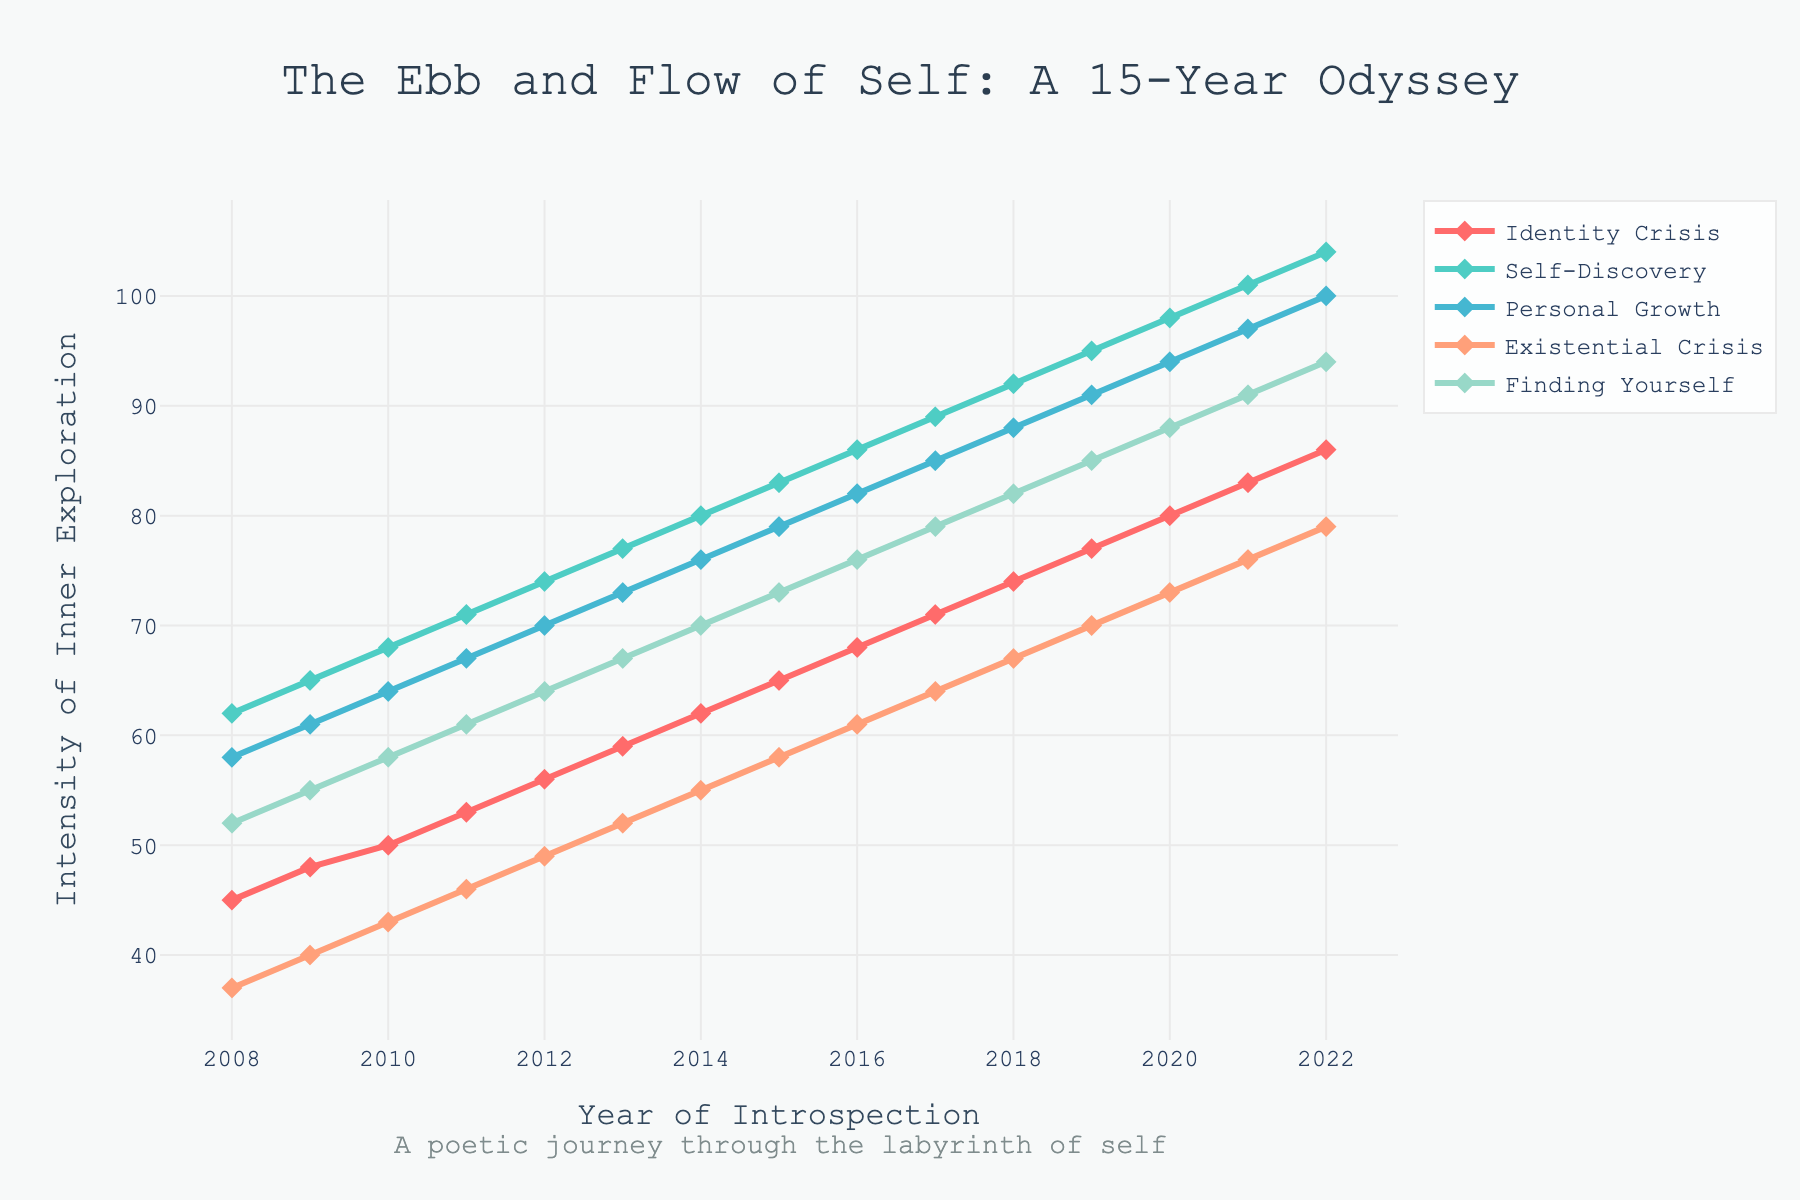What is the overall trend in Google searches for "Identity Crisis" over the past 15 years? The trend for "Identity Crisis" increases steadily from 45 in 2008 to 86 in 2022, showing a consistent upward trajectory.
Answer: Steady upward trend Which year saw the highest Google search volume for "Personal Growth"? By examining the height of the lines, "Personal Growth" reaches its peak in 2022 with a value of 100.
Answer: 2022 How do the search volumes for "Self-Discovery" in 2010 compare to those for "Finding Yourself" in 2010? The search volume for "Self-Discovery" in 2010 is 68, while "Finding Yourself" has a search volume of 58 in the same year.
Answer: Higher for Self-Discovery What is the difference in search volume between "Existential Crisis" and "Finding Yourself" in 2015? In 2015, "Existential Crisis" has a search volume of 58 and "Finding Yourself" has 73. The difference is 73 - 58.
Answer: 15 Which search term had the largest increase in search volume from 2008 to 2022? By comparing the values from 2008 to 2022 for all terms, "Personal Growth" increased from 58 to 100, a change of 42, which seems to be the largest.
Answer: Personal Growth What is the average search volume for "Identity Crisis" over the entire period? The sum of search volumes for "Identity Crisis" is (45 + 48 + 50 + 53 + 56 + 59 + 62 + 65 + 68 + 71 + 74 + 77 + 80 + 83 + 86) = 967. There are 15 years, so the average is 967 / 15.
Answer: Approximately 64.47 Compare the trends in search volume for "Self-Discovery" and "Existential Crisis" between 2010 and 2015. Both trends show a steady increase, but "Self-Discovery" has consistently higher values, increasing from 68 to 83 while "Existential Crisis" increases from 43 to 58.
Answer: Higher for Self-Discovery What is the sum of search volumes for "Finding Yourself" and "Personal Growth" in 2020? In 2020, the search volume for "Finding Yourself" is 88 and "Personal Growth" is 94. The sum is 88 + 94.
Answer: 182 Which term shows the least variation in search volumes over the years? By visually analyzing the smoothness of lines, "Existential Crisis" appears to have the least variation as it consistently shows lower and less steep increases compared to other terms.
Answer: Existential Crisis 